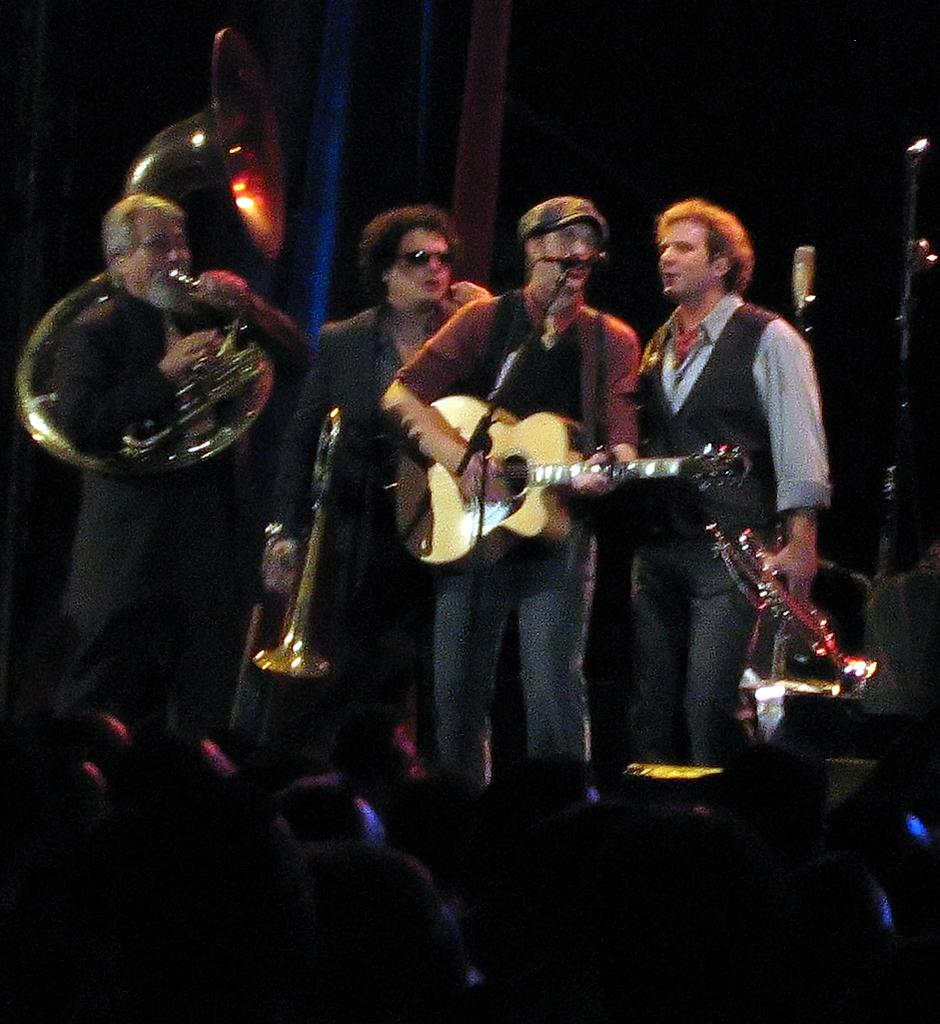How many men are in the image? There are four men in the image. What are the men doing in the image? Each of the men is holding a musical instrument. Can you describe any other objects in the image? There is a microphone in the image. How many people are in the image in total? There are multiple people in the image, including the four men holding musical instruments. What type of crow can be seen interacting with the men's toes in the image? There is no crow present in the image, and the men's toes are not interacting with any animals or objects. 